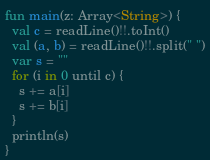Convert code to text. <code><loc_0><loc_0><loc_500><loc_500><_Kotlin_>fun main(z: Array<String>) {
  val c = readLine()!!.toInt()
  val (a, b) = readLine()!!.split(" ")
  var s = ""
  for (i in 0 until c) {
    s += a[i]
    s += b[i]
  }
  println(s)
}</code> 